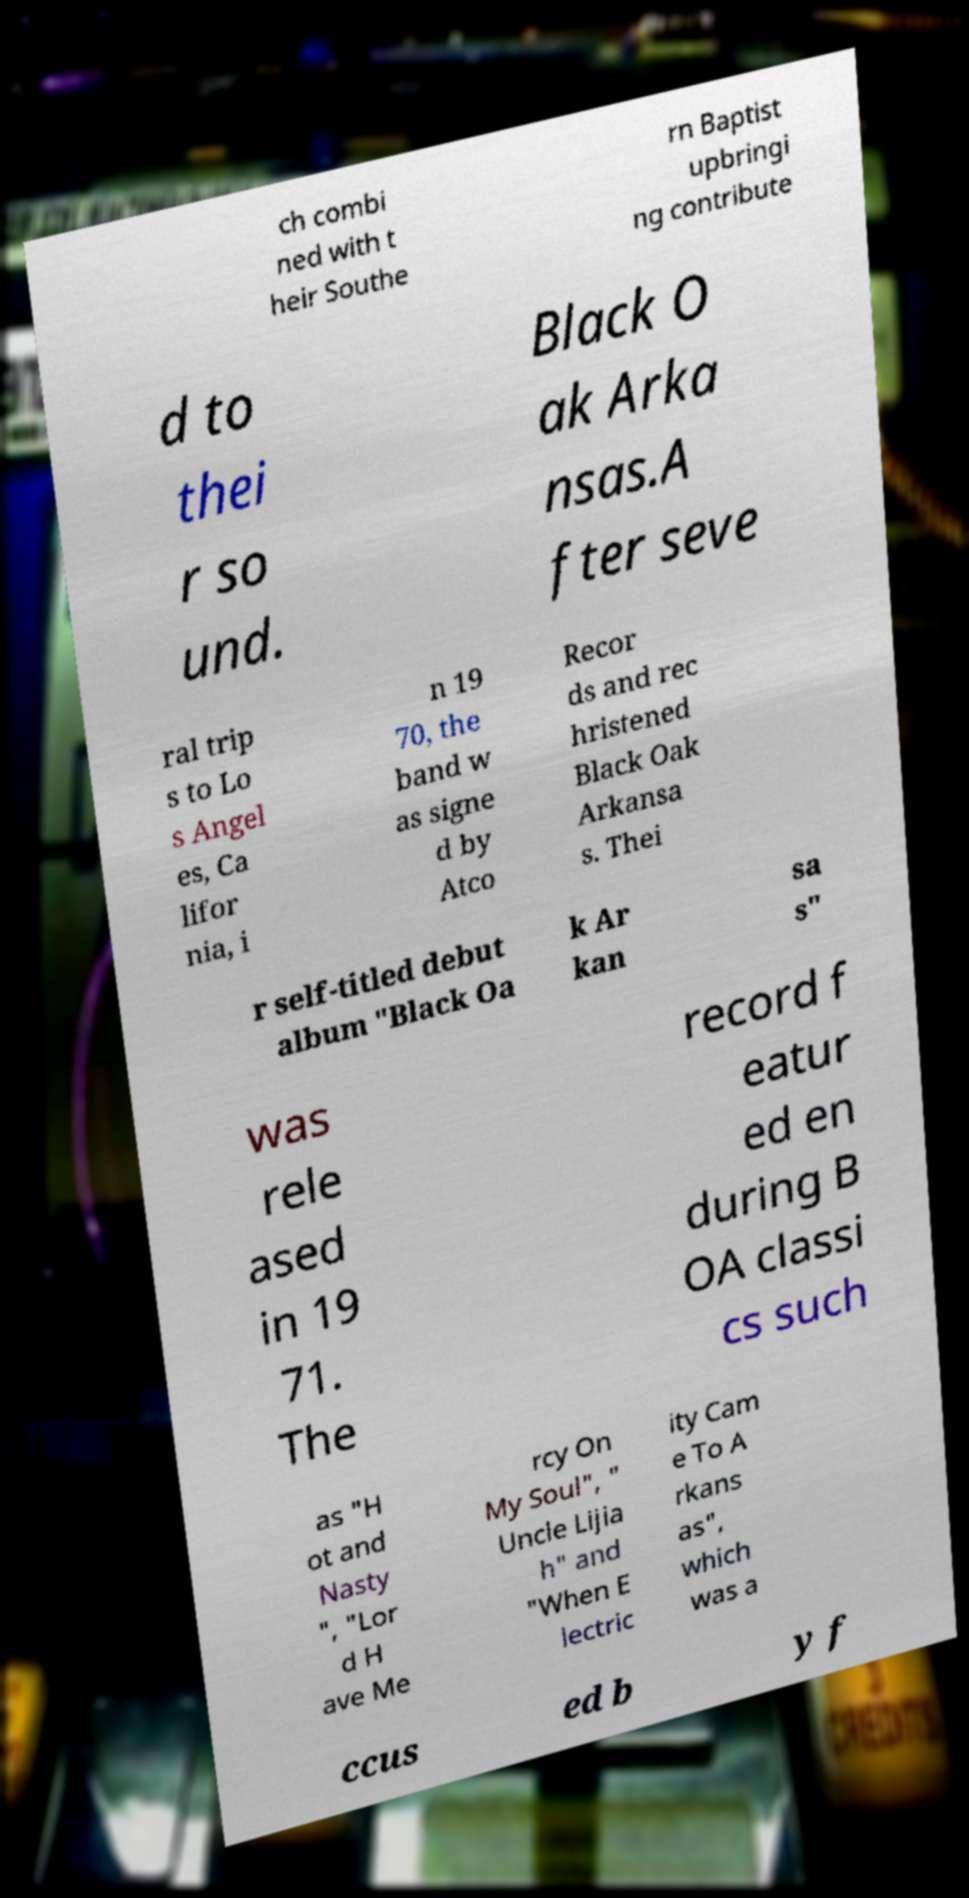I need the written content from this picture converted into text. Can you do that? ch combi ned with t heir Southe rn Baptist upbringi ng contribute d to thei r so und. Black O ak Arka nsas.A fter seve ral trip s to Lo s Angel es, Ca lifor nia, i n 19 70, the band w as signe d by Atco Recor ds and rec hristened Black Oak Arkansa s. Thei r self-titled debut album "Black Oa k Ar kan sa s" was rele ased in 19 71. The record f eatur ed en during B OA classi cs such as "H ot and Nasty ", "Lor d H ave Me rcy On My Soul", " Uncle Lijia h" and "When E lectric ity Cam e To A rkans as", which was a ccus ed b y f 